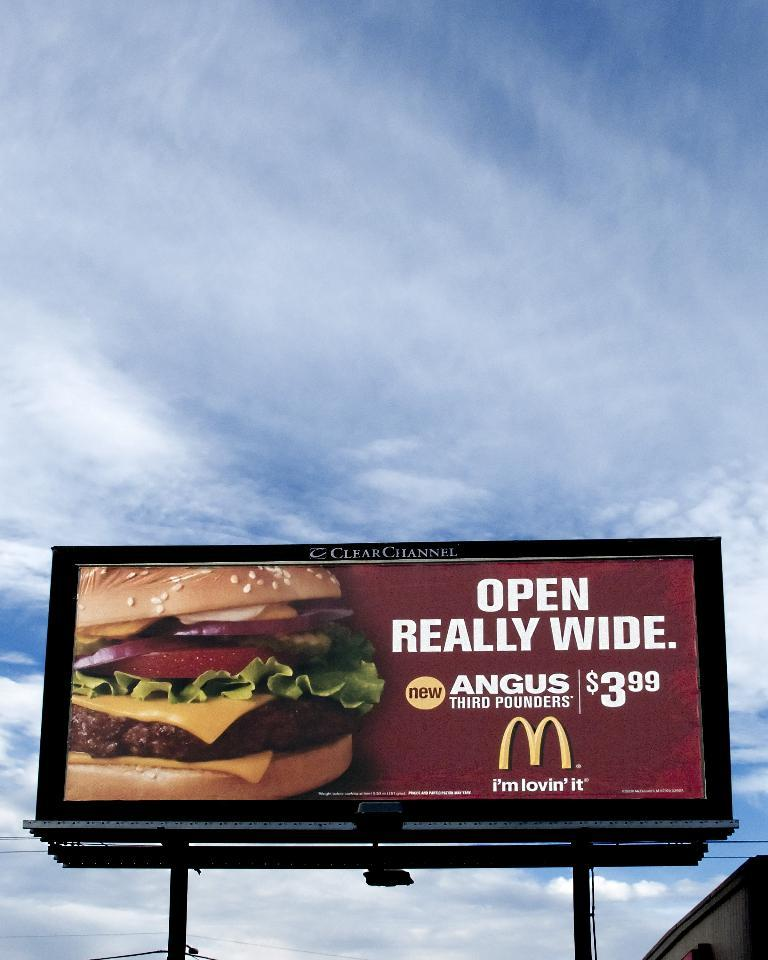<image>
Summarize the visual content of the image. Open Really Wide, advises the billboard for the McDonald's Angus third pounders for only $3.99. 